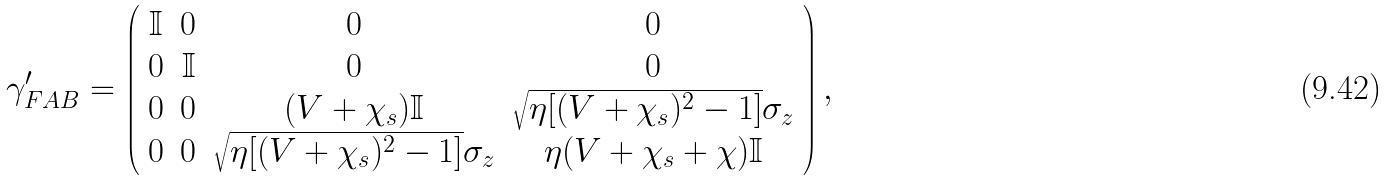Convert formula to latex. <formula><loc_0><loc_0><loc_500><loc_500>\gamma ^ { \prime } _ { F A B } = \left ( \begin{array} { c c c c } \mathbb { I } & 0 & 0 & 0 \\ 0 & \mathbb { I } & 0 & 0 \\ 0 & 0 & ( V + \chi _ { s } ) \mathbb { I } & \sqrt { \eta [ ( V + \chi _ { s } ) ^ { 2 } - 1 ] } \sigma _ { z } \\ 0 & 0 & \sqrt { \eta [ ( V + \chi _ { s } ) ^ { 2 } - 1 ] } \sigma _ { z } & \eta ( V + \chi _ { s } + \chi ) \mathbb { I } \\ \end{array} \right ) ,</formula> 